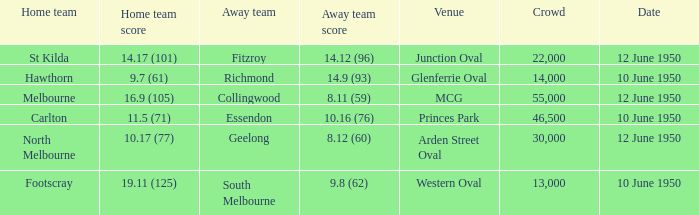Who was the visiting team when the vfl played at mcg? Collingwood. 